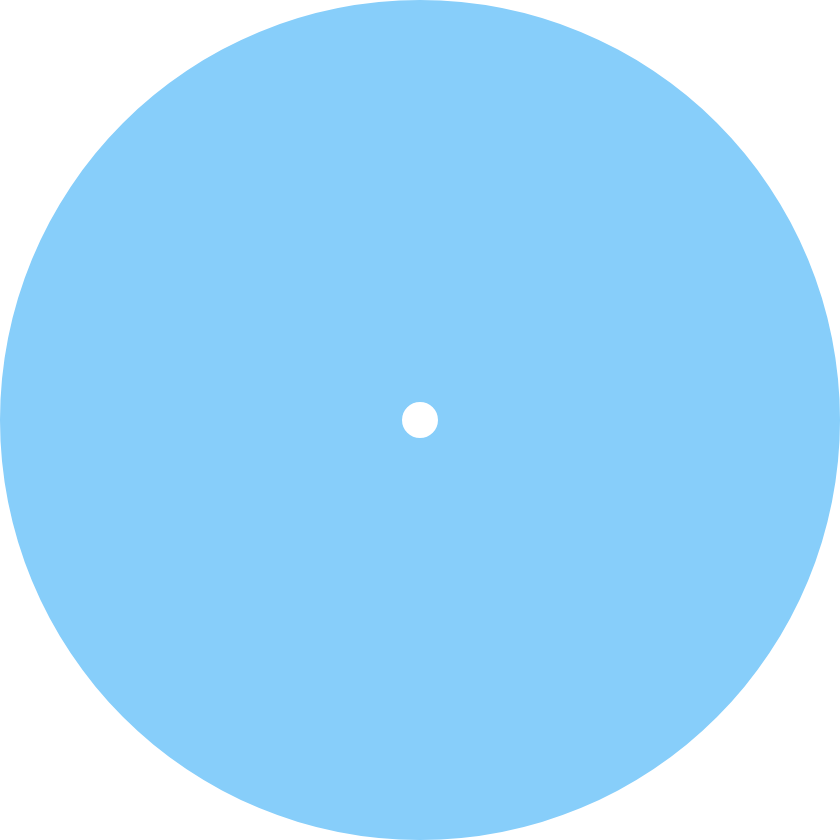Convert chart. <chart><loc_0><loc_0><loc_500><loc_500><pie_chart><ecel><nl><fcel>100.0%<nl></chart> 